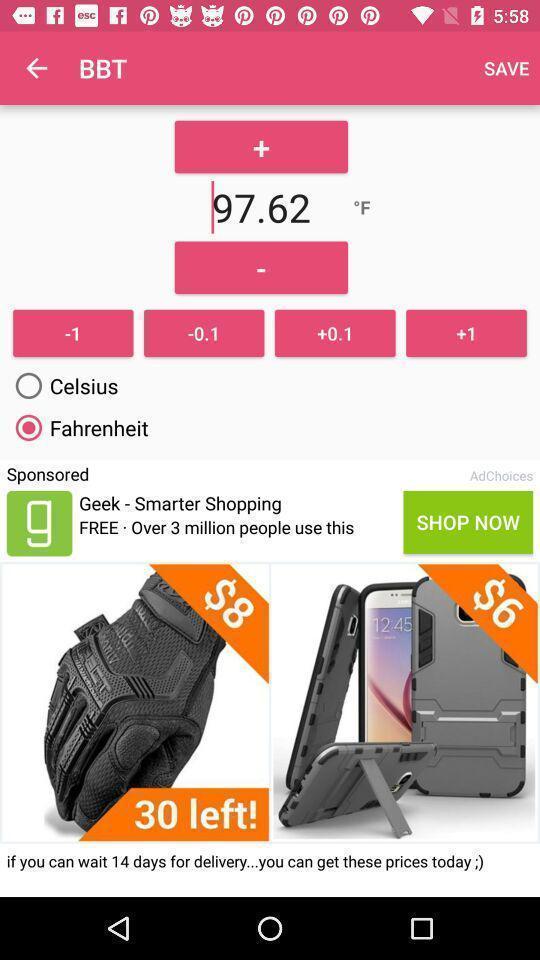What is the overall content of this screenshot? Page showing the options in tracker app. 